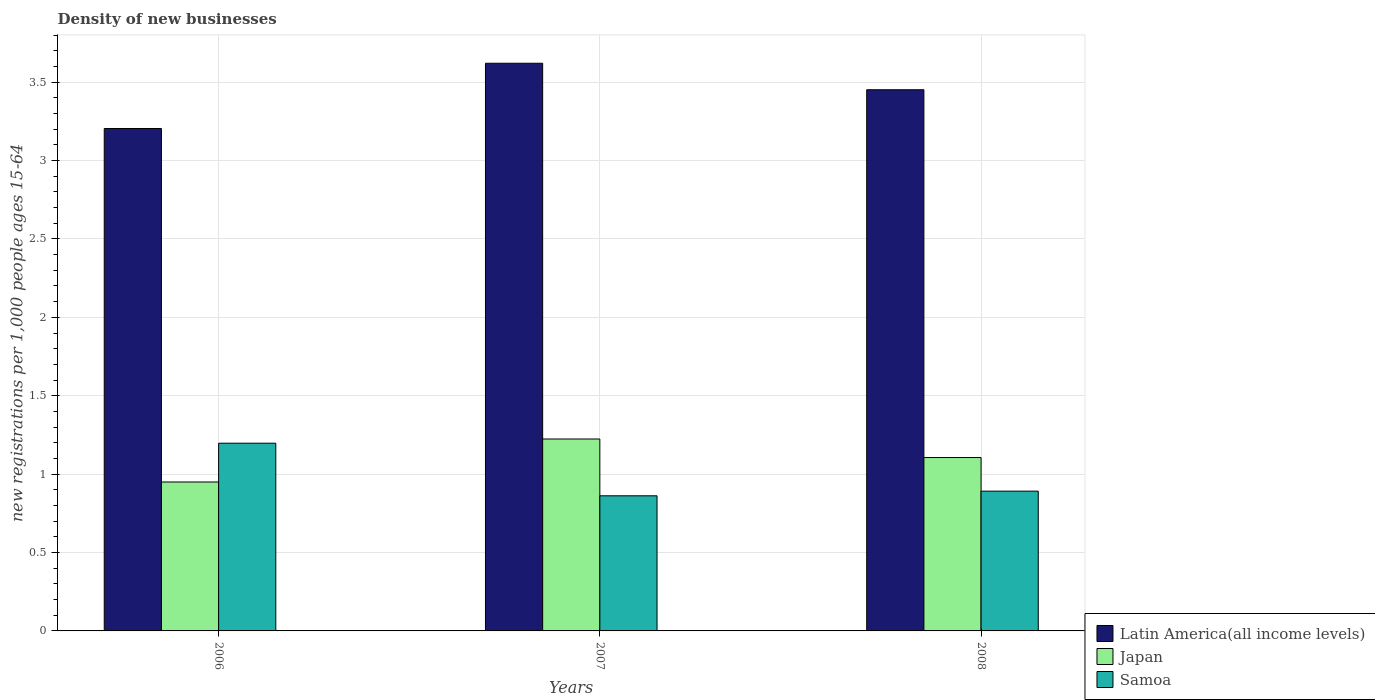Are the number of bars per tick equal to the number of legend labels?
Provide a succinct answer. Yes. How many bars are there on the 3rd tick from the left?
Give a very brief answer. 3. In how many cases, is the number of bars for a given year not equal to the number of legend labels?
Ensure brevity in your answer.  0. What is the number of new registrations in Latin America(all income levels) in 2008?
Offer a terse response. 3.45. Across all years, what is the maximum number of new registrations in Latin America(all income levels)?
Give a very brief answer. 3.62. Across all years, what is the minimum number of new registrations in Latin America(all income levels)?
Provide a short and direct response. 3.2. In which year was the number of new registrations in Latin America(all income levels) maximum?
Offer a terse response. 2007. What is the total number of new registrations in Japan in the graph?
Offer a very short reply. 3.28. What is the difference between the number of new registrations in Samoa in 2006 and that in 2007?
Ensure brevity in your answer.  0.34. What is the difference between the number of new registrations in Samoa in 2007 and the number of new registrations in Japan in 2006?
Your answer should be very brief. -0.09. What is the average number of new registrations in Samoa per year?
Provide a short and direct response. 0.98. In the year 2006, what is the difference between the number of new registrations in Samoa and number of new registrations in Japan?
Your response must be concise. 0.25. What is the ratio of the number of new registrations in Latin America(all income levels) in 2006 to that in 2007?
Provide a succinct answer. 0.89. Is the number of new registrations in Japan in 2006 less than that in 2008?
Give a very brief answer. Yes. Is the difference between the number of new registrations in Samoa in 2006 and 2007 greater than the difference between the number of new registrations in Japan in 2006 and 2007?
Ensure brevity in your answer.  Yes. What is the difference between the highest and the second highest number of new registrations in Samoa?
Make the answer very short. 0.31. What is the difference between the highest and the lowest number of new registrations in Japan?
Offer a very short reply. 0.27. What does the 1st bar from the left in 2007 represents?
Provide a short and direct response. Latin America(all income levels). What does the 2nd bar from the right in 2007 represents?
Offer a terse response. Japan. Is it the case that in every year, the sum of the number of new registrations in Latin America(all income levels) and number of new registrations in Japan is greater than the number of new registrations in Samoa?
Your answer should be very brief. Yes. Are all the bars in the graph horizontal?
Offer a terse response. No. How many years are there in the graph?
Your answer should be compact. 3. Does the graph contain grids?
Give a very brief answer. Yes. What is the title of the graph?
Make the answer very short. Density of new businesses. Does "Guam" appear as one of the legend labels in the graph?
Provide a succinct answer. No. What is the label or title of the X-axis?
Give a very brief answer. Years. What is the label or title of the Y-axis?
Keep it short and to the point. New registrations per 1,0 people ages 15-64. What is the new registrations per 1,000 people ages 15-64 of Latin America(all income levels) in 2006?
Make the answer very short. 3.2. What is the new registrations per 1,000 people ages 15-64 in Japan in 2006?
Offer a terse response. 0.95. What is the new registrations per 1,000 people ages 15-64 in Samoa in 2006?
Provide a succinct answer. 1.2. What is the new registrations per 1,000 people ages 15-64 in Latin America(all income levels) in 2007?
Make the answer very short. 3.62. What is the new registrations per 1,000 people ages 15-64 of Japan in 2007?
Your answer should be very brief. 1.22. What is the new registrations per 1,000 people ages 15-64 in Samoa in 2007?
Keep it short and to the point. 0.86. What is the new registrations per 1,000 people ages 15-64 in Latin America(all income levels) in 2008?
Make the answer very short. 3.45. What is the new registrations per 1,000 people ages 15-64 of Japan in 2008?
Give a very brief answer. 1.11. What is the new registrations per 1,000 people ages 15-64 of Samoa in 2008?
Give a very brief answer. 0.89. Across all years, what is the maximum new registrations per 1,000 people ages 15-64 in Latin America(all income levels)?
Make the answer very short. 3.62. Across all years, what is the maximum new registrations per 1,000 people ages 15-64 of Japan?
Ensure brevity in your answer.  1.22. Across all years, what is the maximum new registrations per 1,000 people ages 15-64 in Samoa?
Offer a very short reply. 1.2. Across all years, what is the minimum new registrations per 1,000 people ages 15-64 in Latin America(all income levels)?
Ensure brevity in your answer.  3.2. Across all years, what is the minimum new registrations per 1,000 people ages 15-64 in Japan?
Offer a very short reply. 0.95. Across all years, what is the minimum new registrations per 1,000 people ages 15-64 in Samoa?
Keep it short and to the point. 0.86. What is the total new registrations per 1,000 people ages 15-64 in Latin America(all income levels) in the graph?
Make the answer very short. 10.28. What is the total new registrations per 1,000 people ages 15-64 of Japan in the graph?
Keep it short and to the point. 3.28. What is the total new registrations per 1,000 people ages 15-64 of Samoa in the graph?
Make the answer very short. 2.95. What is the difference between the new registrations per 1,000 people ages 15-64 of Latin America(all income levels) in 2006 and that in 2007?
Make the answer very short. -0.42. What is the difference between the new registrations per 1,000 people ages 15-64 in Japan in 2006 and that in 2007?
Your response must be concise. -0.27. What is the difference between the new registrations per 1,000 people ages 15-64 in Samoa in 2006 and that in 2007?
Your response must be concise. 0.34. What is the difference between the new registrations per 1,000 people ages 15-64 of Latin America(all income levels) in 2006 and that in 2008?
Provide a short and direct response. -0.25. What is the difference between the new registrations per 1,000 people ages 15-64 of Japan in 2006 and that in 2008?
Your answer should be compact. -0.16. What is the difference between the new registrations per 1,000 people ages 15-64 in Samoa in 2006 and that in 2008?
Make the answer very short. 0.31. What is the difference between the new registrations per 1,000 people ages 15-64 of Latin America(all income levels) in 2007 and that in 2008?
Your response must be concise. 0.17. What is the difference between the new registrations per 1,000 people ages 15-64 of Japan in 2007 and that in 2008?
Ensure brevity in your answer.  0.12. What is the difference between the new registrations per 1,000 people ages 15-64 in Samoa in 2007 and that in 2008?
Your response must be concise. -0.03. What is the difference between the new registrations per 1,000 people ages 15-64 in Latin America(all income levels) in 2006 and the new registrations per 1,000 people ages 15-64 in Japan in 2007?
Provide a short and direct response. 1.98. What is the difference between the new registrations per 1,000 people ages 15-64 in Latin America(all income levels) in 2006 and the new registrations per 1,000 people ages 15-64 in Samoa in 2007?
Provide a succinct answer. 2.34. What is the difference between the new registrations per 1,000 people ages 15-64 in Japan in 2006 and the new registrations per 1,000 people ages 15-64 in Samoa in 2007?
Offer a terse response. 0.09. What is the difference between the new registrations per 1,000 people ages 15-64 in Latin America(all income levels) in 2006 and the new registrations per 1,000 people ages 15-64 in Japan in 2008?
Ensure brevity in your answer.  2.1. What is the difference between the new registrations per 1,000 people ages 15-64 in Latin America(all income levels) in 2006 and the new registrations per 1,000 people ages 15-64 in Samoa in 2008?
Provide a short and direct response. 2.31. What is the difference between the new registrations per 1,000 people ages 15-64 of Japan in 2006 and the new registrations per 1,000 people ages 15-64 of Samoa in 2008?
Your answer should be compact. 0.06. What is the difference between the new registrations per 1,000 people ages 15-64 in Latin America(all income levels) in 2007 and the new registrations per 1,000 people ages 15-64 in Japan in 2008?
Your answer should be very brief. 2.51. What is the difference between the new registrations per 1,000 people ages 15-64 in Latin America(all income levels) in 2007 and the new registrations per 1,000 people ages 15-64 in Samoa in 2008?
Ensure brevity in your answer.  2.73. What is the difference between the new registrations per 1,000 people ages 15-64 in Japan in 2007 and the new registrations per 1,000 people ages 15-64 in Samoa in 2008?
Offer a terse response. 0.33. What is the average new registrations per 1,000 people ages 15-64 of Latin America(all income levels) per year?
Give a very brief answer. 3.43. What is the average new registrations per 1,000 people ages 15-64 in Japan per year?
Provide a short and direct response. 1.09. What is the average new registrations per 1,000 people ages 15-64 in Samoa per year?
Give a very brief answer. 0.98. In the year 2006, what is the difference between the new registrations per 1,000 people ages 15-64 in Latin America(all income levels) and new registrations per 1,000 people ages 15-64 in Japan?
Offer a terse response. 2.25. In the year 2006, what is the difference between the new registrations per 1,000 people ages 15-64 in Latin America(all income levels) and new registrations per 1,000 people ages 15-64 in Samoa?
Ensure brevity in your answer.  2.01. In the year 2006, what is the difference between the new registrations per 1,000 people ages 15-64 of Japan and new registrations per 1,000 people ages 15-64 of Samoa?
Your answer should be very brief. -0.25. In the year 2007, what is the difference between the new registrations per 1,000 people ages 15-64 in Latin America(all income levels) and new registrations per 1,000 people ages 15-64 in Japan?
Your answer should be compact. 2.4. In the year 2007, what is the difference between the new registrations per 1,000 people ages 15-64 of Latin America(all income levels) and new registrations per 1,000 people ages 15-64 of Samoa?
Offer a terse response. 2.76. In the year 2007, what is the difference between the new registrations per 1,000 people ages 15-64 in Japan and new registrations per 1,000 people ages 15-64 in Samoa?
Ensure brevity in your answer.  0.36. In the year 2008, what is the difference between the new registrations per 1,000 people ages 15-64 of Latin America(all income levels) and new registrations per 1,000 people ages 15-64 of Japan?
Offer a very short reply. 2.35. In the year 2008, what is the difference between the new registrations per 1,000 people ages 15-64 of Latin America(all income levels) and new registrations per 1,000 people ages 15-64 of Samoa?
Your answer should be compact. 2.56. In the year 2008, what is the difference between the new registrations per 1,000 people ages 15-64 in Japan and new registrations per 1,000 people ages 15-64 in Samoa?
Provide a succinct answer. 0.21. What is the ratio of the new registrations per 1,000 people ages 15-64 of Latin America(all income levels) in 2006 to that in 2007?
Make the answer very short. 0.89. What is the ratio of the new registrations per 1,000 people ages 15-64 of Japan in 2006 to that in 2007?
Make the answer very short. 0.78. What is the ratio of the new registrations per 1,000 people ages 15-64 in Samoa in 2006 to that in 2007?
Keep it short and to the point. 1.39. What is the ratio of the new registrations per 1,000 people ages 15-64 of Latin America(all income levels) in 2006 to that in 2008?
Give a very brief answer. 0.93. What is the ratio of the new registrations per 1,000 people ages 15-64 in Japan in 2006 to that in 2008?
Your answer should be very brief. 0.86. What is the ratio of the new registrations per 1,000 people ages 15-64 of Samoa in 2006 to that in 2008?
Provide a succinct answer. 1.34. What is the ratio of the new registrations per 1,000 people ages 15-64 in Latin America(all income levels) in 2007 to that in 2008?
Give a very brief answer. 1.05. What is the ratio of the new registrations per 1,000 people ages 15-64 in Japan in 2007 to that in 2008?
Your answer should be very brief. 1.11. What is the ratio of the new registrations per 1,000 people ages 15-64 of Samoa in 2007 to that in 2008?
Make the answer very short. 0.97. What is the difference between the highest and the second highest new registrations per 1,000 people ages 15-64 of Latin America(all income levels)?
Offer a very short reply. 0.17. What is the difference between the highest and the second highest new registrations per 1,000 people ages 15-64 of Japan?
Offer a terse response. 0.12. What is the difference between the highest and the second highest new registrations per 1,000 people ages 15-64 in Samoa?
Make the answer very short. 0.31. What is the difference between the highest and the lowest new registrations per 1,000 people ages 15-64 in Latin America(all income levels)?
Your answer should be very brief. 0.42. What is the difference between the highest and the lowest new registrations per 1,000 people ages 15-64 in Japan?
Provide a succinct answer. 0.27. What is the difference between the highest and the lowest new registrations per 1,000 people ages 15-64 of Samoa?
Offer a terse response. 0.34. 